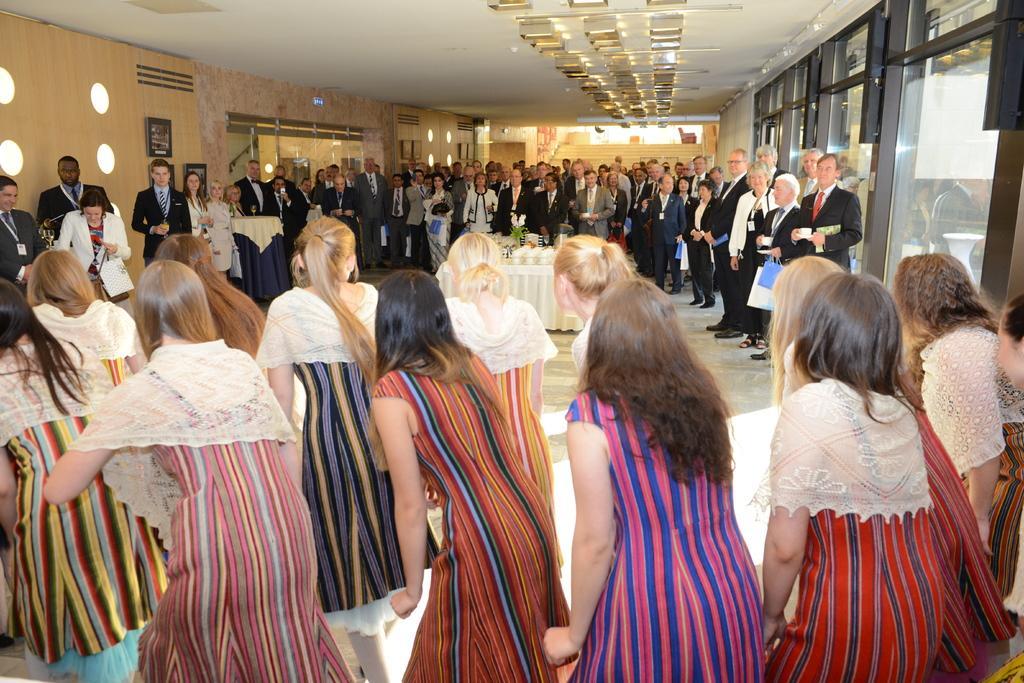Could you give a brief overview of what you see in this image? This picture is clicked inside. In the foreground we can see the group of woman standing on the ground. In the center there is a table on the top of which some items are placed. In the background we can see the group of people holding some objects and standing. At the top there is a roof and we can see the doors and some other objects. 